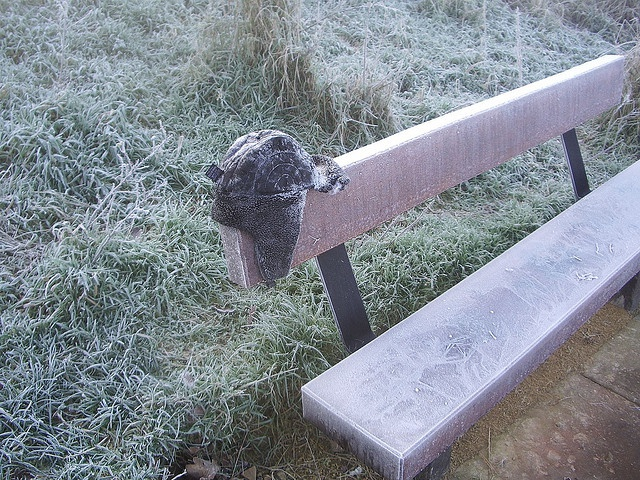Describe the objects in this image and their specific colors. I can see a bench in gray, darkgray, and lavender tones in this image. 